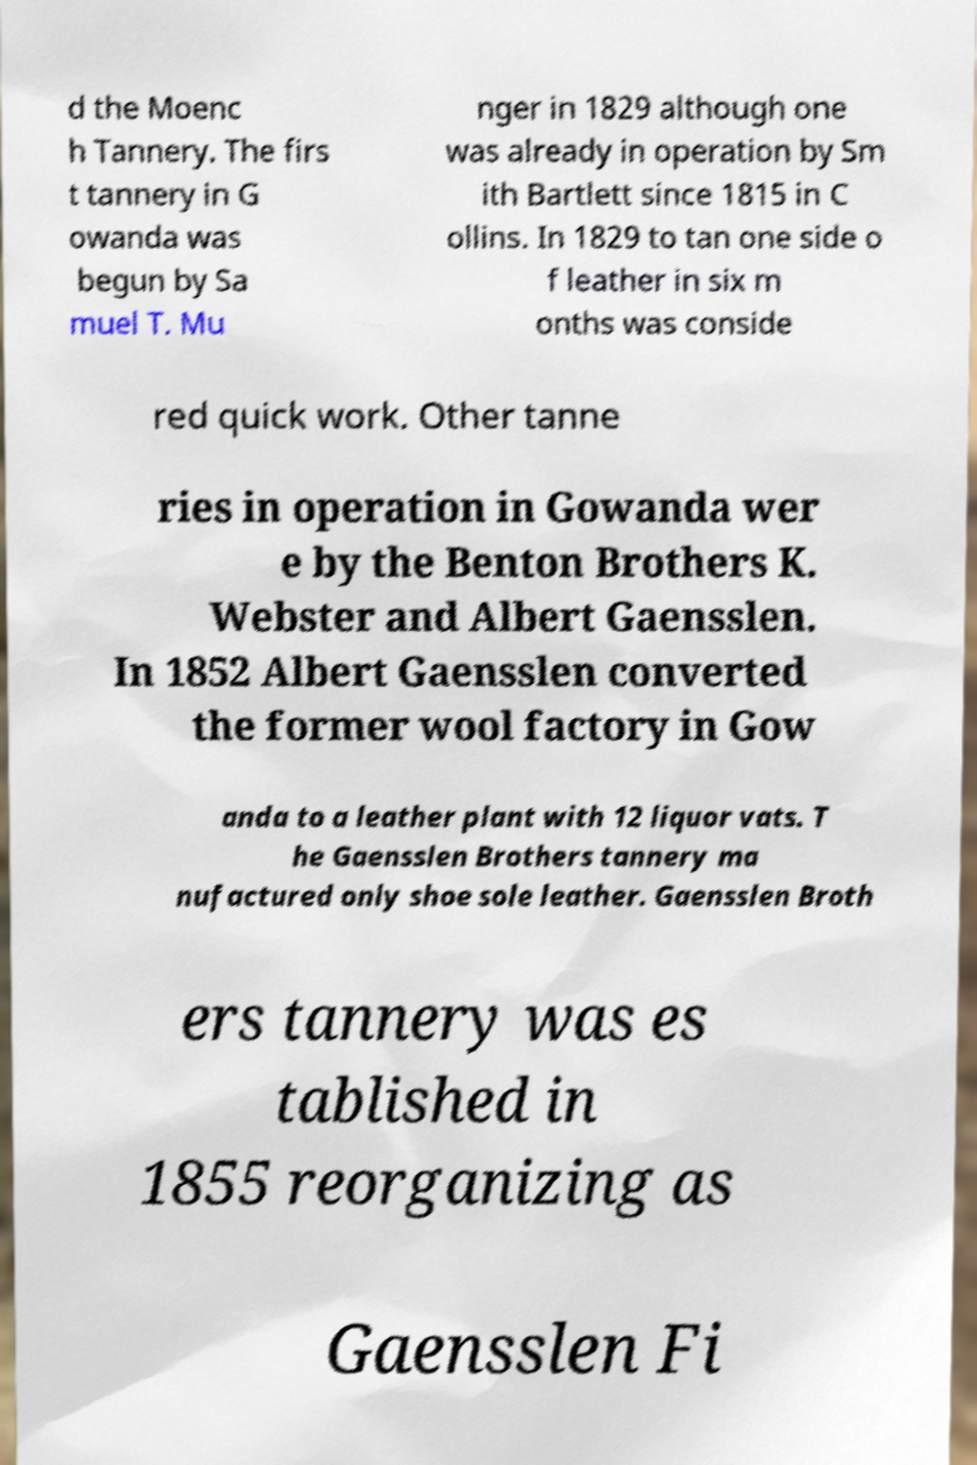Could you extract and type out the text from this image? d the Moenc h Tannery. The firs t tannery in G owanda was begun by Sa muel T. Mu nger in 1829 although one was already in operation by Sm ith Bartlett since 1815 in C ollins. In 1829 to tan one side o f leather in six m onths was conside red quick work. Other tanne ries in operation in Gowanda wer e by the Benton Brothers K. Webster and Albert Gaensslen. In 1852 Albert Gaensslen converted the former wool factory in Gow anda to a leather plant with 12 liquor vats. T he Gaensslen Brothers tannery ma nufactured only shoe sole leather. Gaensslen Broth ers tannery was es tablished in 1855 reorganizing as Gaensslen Fi 